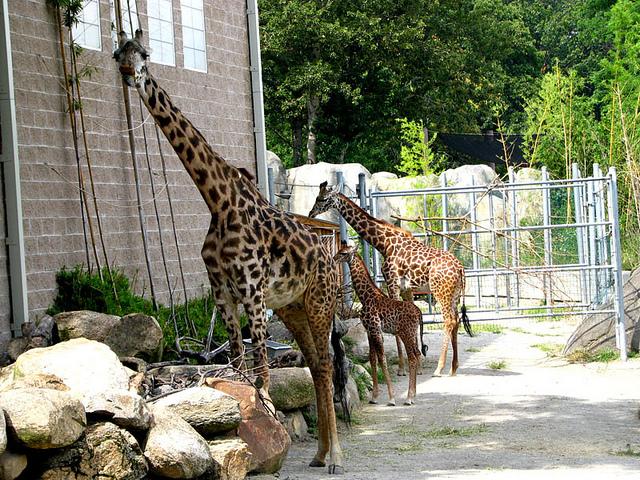IS there a fence in this pic?
Quick response, please. Yes. How many rocks are piled to the left of the larger giraffe?
Short answer required. 20. How many giraffes are there?
Short answer required. 3. 